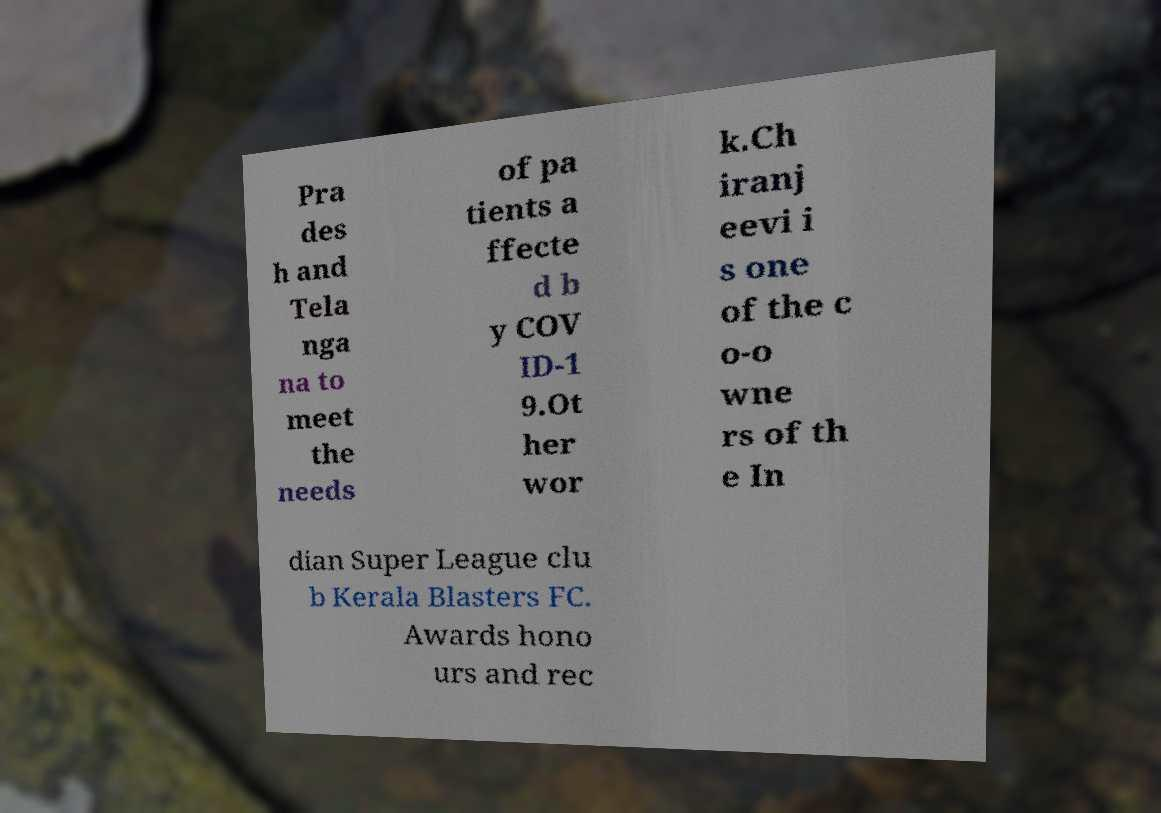There's text embedded in this image that I need extracted. Can you transcribe it verbatim? Pra des h and Tela nga na to meet the needs of pa tients a ffecte d b y COV ID-1 9.Ot her wor k.Ch iranj eevi i s one of the c o-o wne rs of th e In dian Super League clu b Kerala Blasters FC. Awards hono urs and rec 